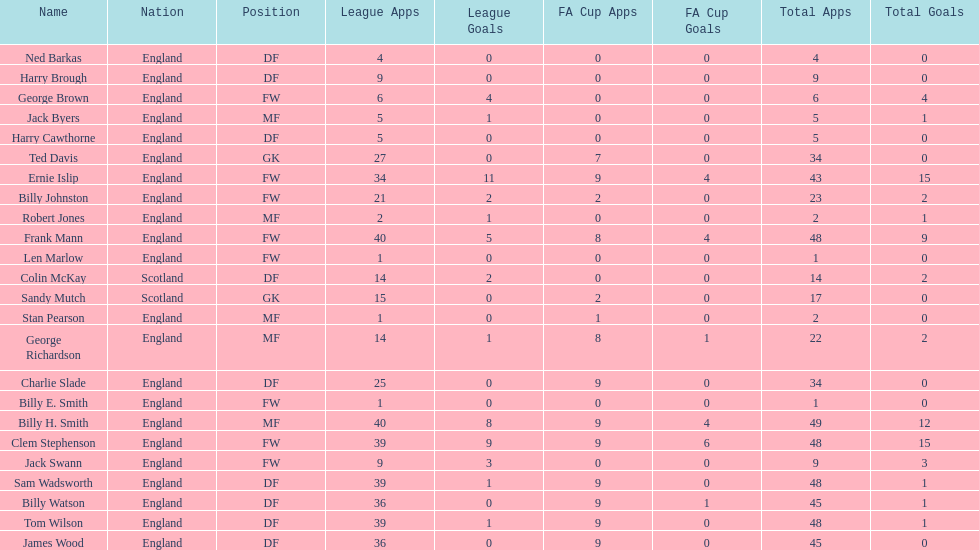What is the mean number of goals that scottish players score? 1. 